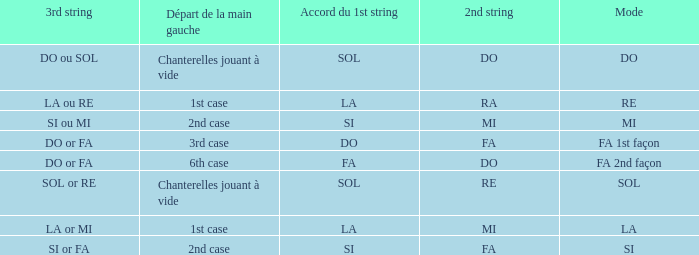What is the Depart de la main gauche of the do Mode? Chanterelles jouant à vide. 